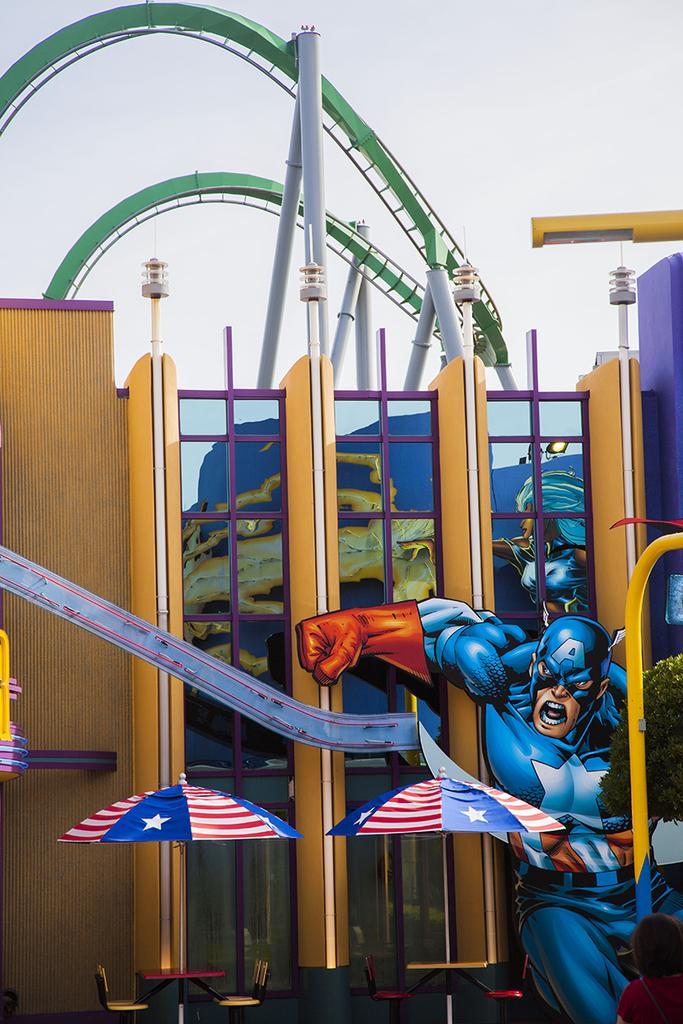In one or two sentences, can you explain what this image depicts? This is an edited picture and in this picture we can see tables, chairs, umbrellas, building, some people, light, poles and some objects and in the background we can see the sky. 